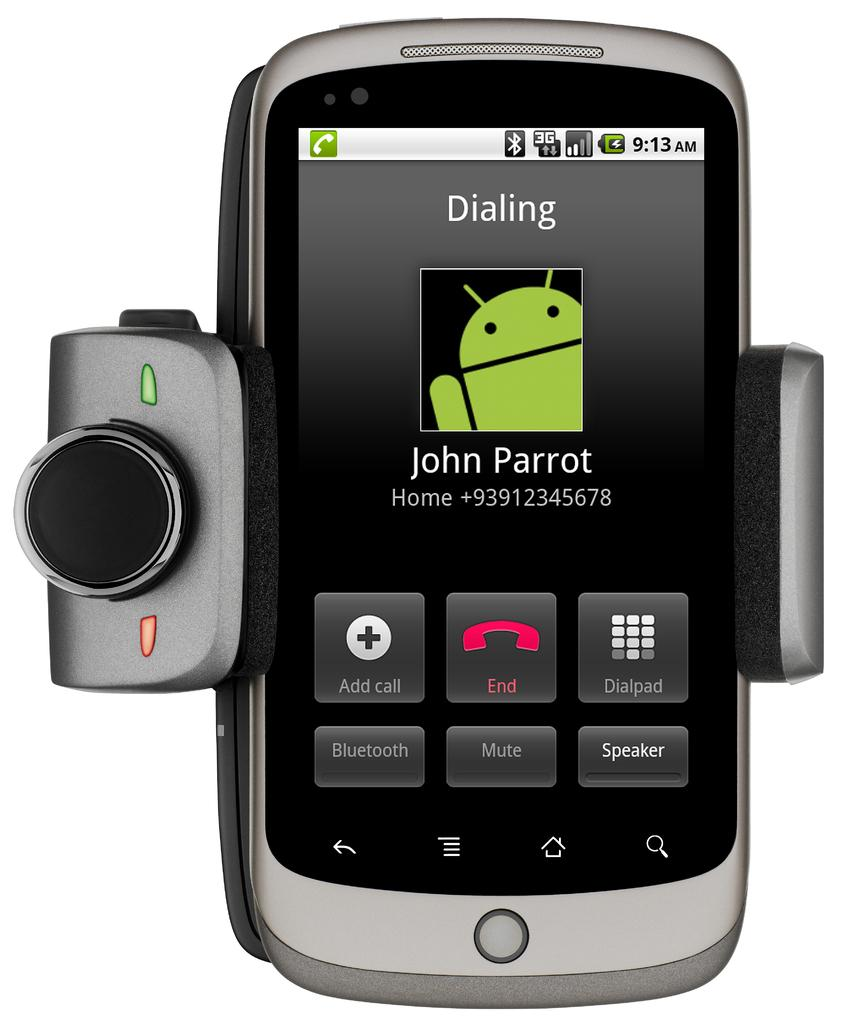Provide a one-sentence caption for the provided image. A phone that is dialing John Parrot and has no photo. 